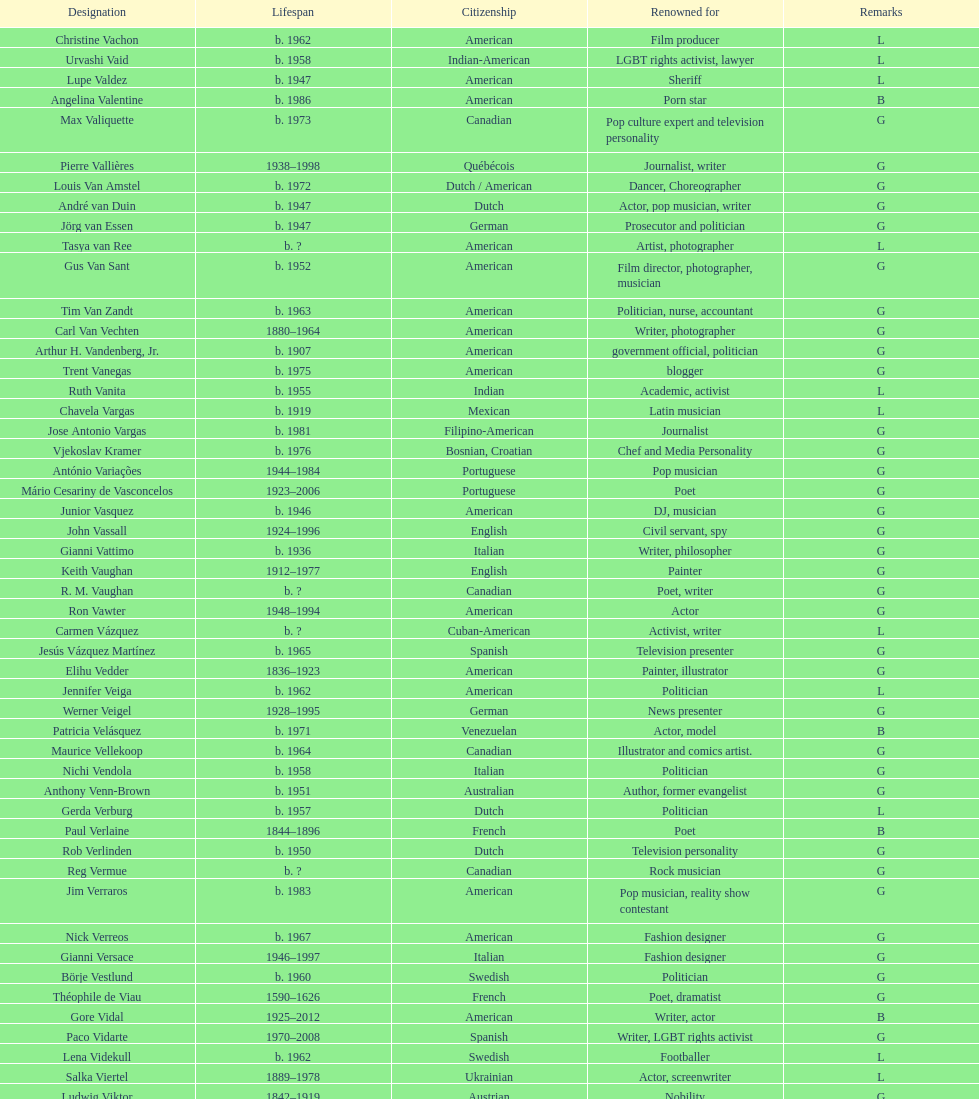What is the number of individuals in this group who were indian? 1. 